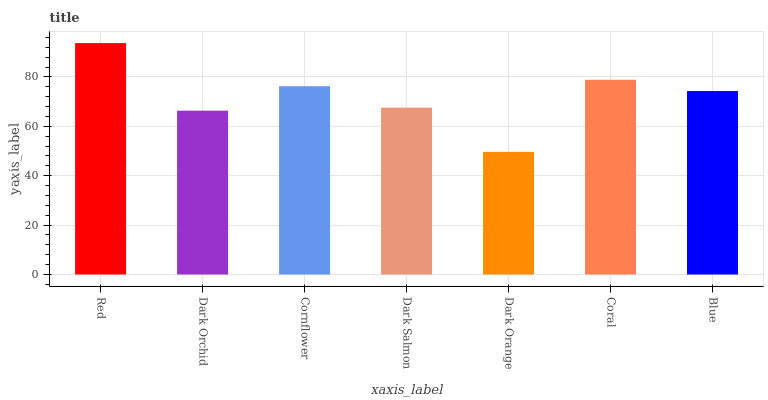Is Dark Orange the minimum?
Answer yes or no. Yes. Is Red the maximum?
Answer yes or no. Yes. Is Dark Orchid the minimum?
Answer yes or no. No. Is Dark Orchid the maximum?
Answer yes or no. No. Is Red greater than Dark Orchid?
Answer yes or no. Yes. Is Dark Orchid less than Red?
Answer yes or no. Yes. Is Dark Orchid greater than Red?
Answer yes or no. No. Is Red less than Dark Orchid?
Answer yes or no. No. Is Blue the high median?
Answer yes or no. Yes. Is Blue the low median?
Answer yes or no. Yes. Is Coral the high median?
Answer yes or no. No. Is Red the low median?
Answer yes or no. No. 